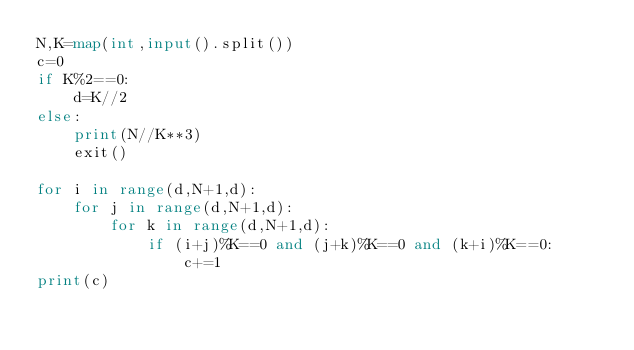<code> <loc_0><loc_0><loc_500><loc_500><_Python_>N,K=map(int,input().split())
c=0
if K%2==0:
    d=K//2
else:
    print(N//K**3)
    exit()

for i in range(d,N+1,d):
    for j in range(d,N+1,d):
        for k in range(d,N+1,d):
            if (i+j)%K==0 and (j+k)%K==0 and (k+i)%K==0:
                c+=1
print(c)</code> 